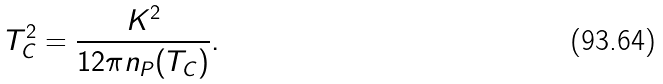Convert formula to latex. <formula><loc_0><loc_0><loc_500><loc_500>T _ { C } ^ { 2 } = \frac { K ^ { 2 } } { 1 2 \pi n _ { P } ( T _ { C } ) } .</formula> 